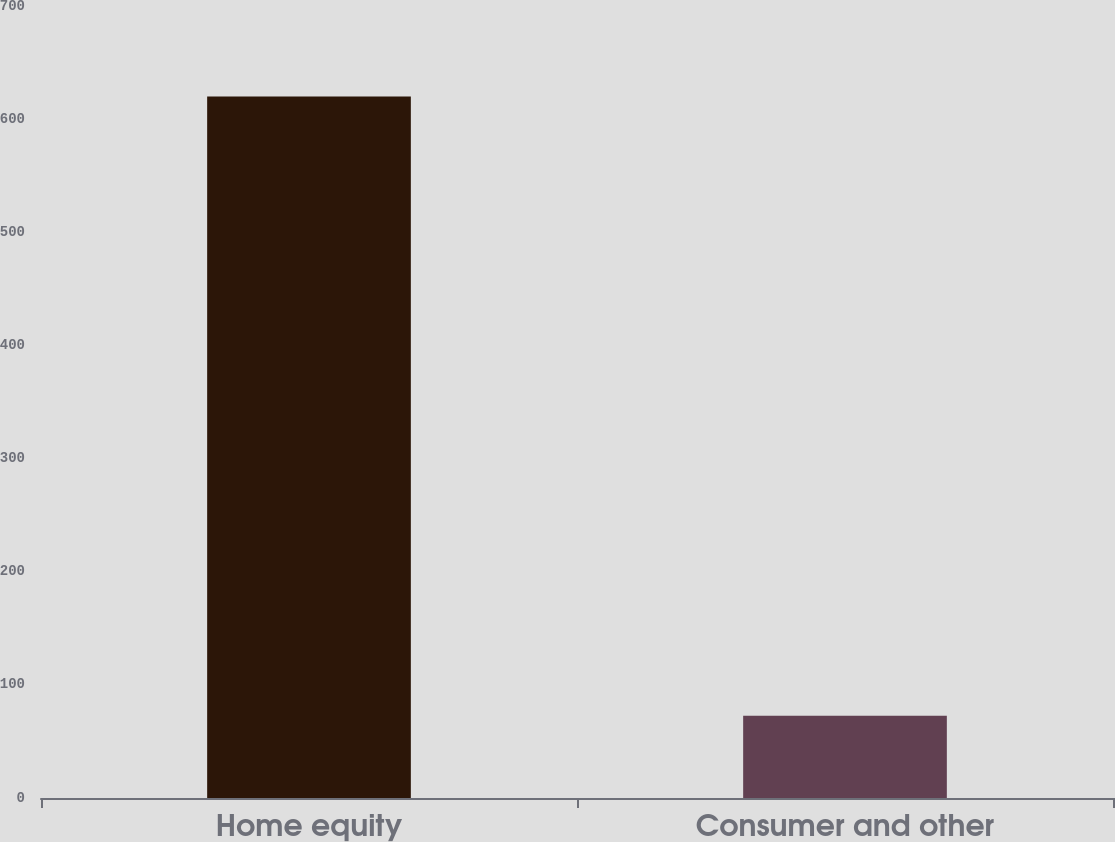Convert chart. <chart><loc_0><loc_0><loc_500><loc_500><bar_chart><fcel>Home equity<fcel>Consumer and other<nl><fcel>620<fcel>72.8<nl></chart> 